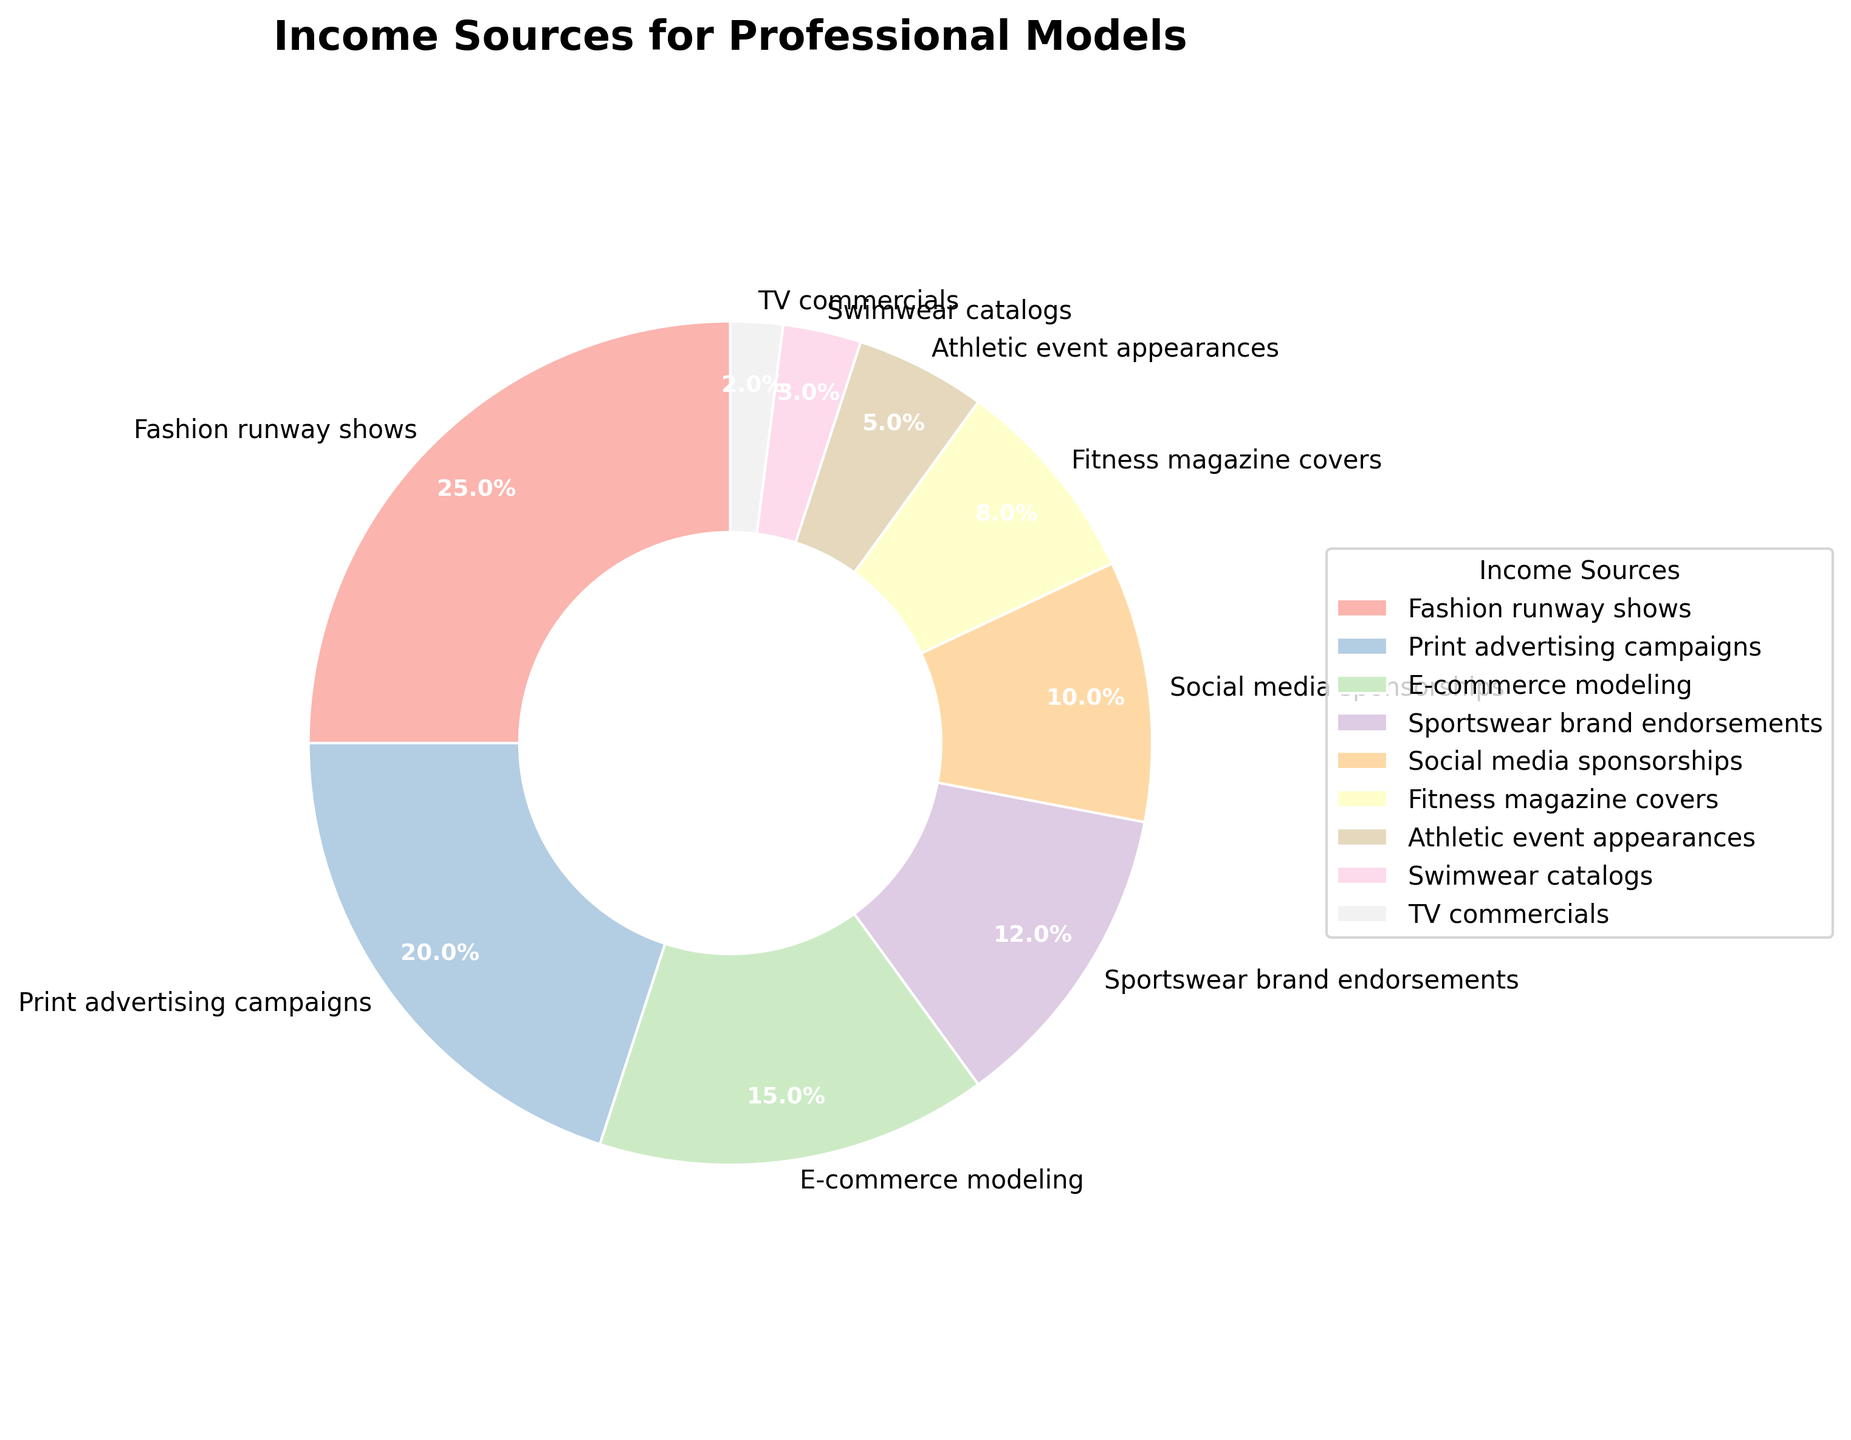Which income source contributes the largest percentage? Look at the slices of the pie chart to see which one occupies the most space. The "Fashion runway shows" slice is the largest at 25%.
Answer: Fashion runway shows What is the combined percentage of income from "E-commerce modeling" and "Social media sponsorships"? Find the percentage for both "E-commerce modeling" and "Social media sponsorships", then add them together: 15% + 10% = 25%.
Answer: 25% Which income source generates the least amount of income for professional models? Check the pie chart and identify the smallest slice. The "TV commercials" slice is the smallest at 2%.
Answer: TV commercials How much more percentage does "Print advertising campaigns" contribute compared to "Athletic event appearances"? Find the percentage for both "Print advertising campaigns" (20%) and "Athletic event appearances" (5%), then subtract the smaller from the larger: 20% - 5% = 15%.
Answer: 15% What is the total percentage of income from all modeling activities related to sports and fitness (combined percentage of "Sportswear brand endorsements" and "Fitness magazine covers")? Add the percentages of "Sportswear brand endorsements" (12%) and "Fitness magazine covers" (8%): 12% + 8% = 20%.
Answer: 20% If incomes from "Swimwear catalogs" and "TV commercials" were combined into a single category, what would be the percentage representation of this new category? Add the percentages of "Swimwear catalogs" (3%) and "TV commercials" (2%): 3% + 2% = 5%.
Answer: 5% Which has a higher income percentage, "Social media sponsorships" or "Fitness magazine covers"? Compare the percentage values: "Social media sponsorships" (10%) vs. "Fitness magazine covers" (8%).
Answer: Social media sponsorships How much lower is the percentage of income from "Swimwear catalogs" compared to "Sportswear brand endorsements"? Find the percentages for both "Swimwear catalogs" (3%) and "Sportswear brand endorsements" (12%), then subtract the smaller from the larger: 12% - 3% = 9%.
Answer: 9% What fraction of the income sources are represented by "Print advertising campaigns" and "E-commerce modeling" together (given as a percentage)? Add the percentages of both "Print advertising campaigns" (20%) and "E-commerce modeling" (15%) to get the total: 20% + 15% = 35%.
Answer: 35% Which category contributes more income, "Swimwear catalogs" or "Athletic event appearances"? Compare the percentage values of both categories: "Swimwear catalogs" (3%) vs. "Athletic event appearances" (5%).
Answer: Athletic event appearances 